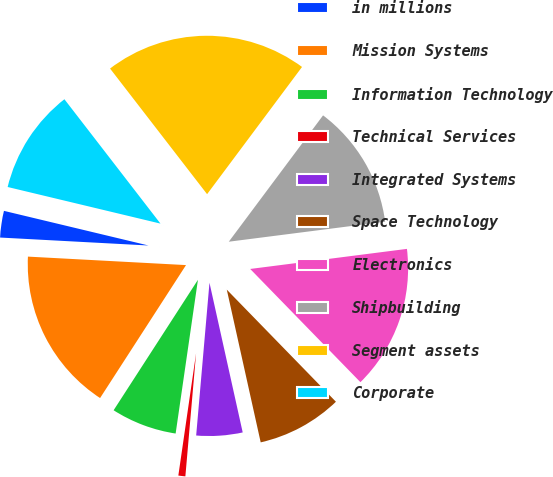Convert chart to OTSL. <chart><loc_0><loc_0><loc_500><loc_500><pie_chart><fcel>in millions<fcel>Mission Systems<fcel>Information Technology<fcel>Technical Services<fcel>Integrated Systems<fcel>Space Technology<fcel>Electronics<fcel>Shipbuilding<fcel>Segment assets<fcel>Corporate<nl><fcel>2.89%<fcel>16.72%<fcel>6.84%<fcel>0.91%<fcel>4.86%<fcel>8.81%<fcel>14.74%<fcel>12.77%<fcel>20.67%<fcel>10.79%<nl></chart> 